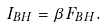<formula> <loc_0><loc_0><loc_500><loc_500>I _ { B H } = \beta F _ { B H } .</formula> 